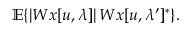<formula> <loc_0><loc_0><loc_500><loc_500>{ \mathbb { E } } \{ | W x [ u , \lambda ] | \, W x [ u , \lambda ^ { \prime } ] ^ { * } \} .</formula> 